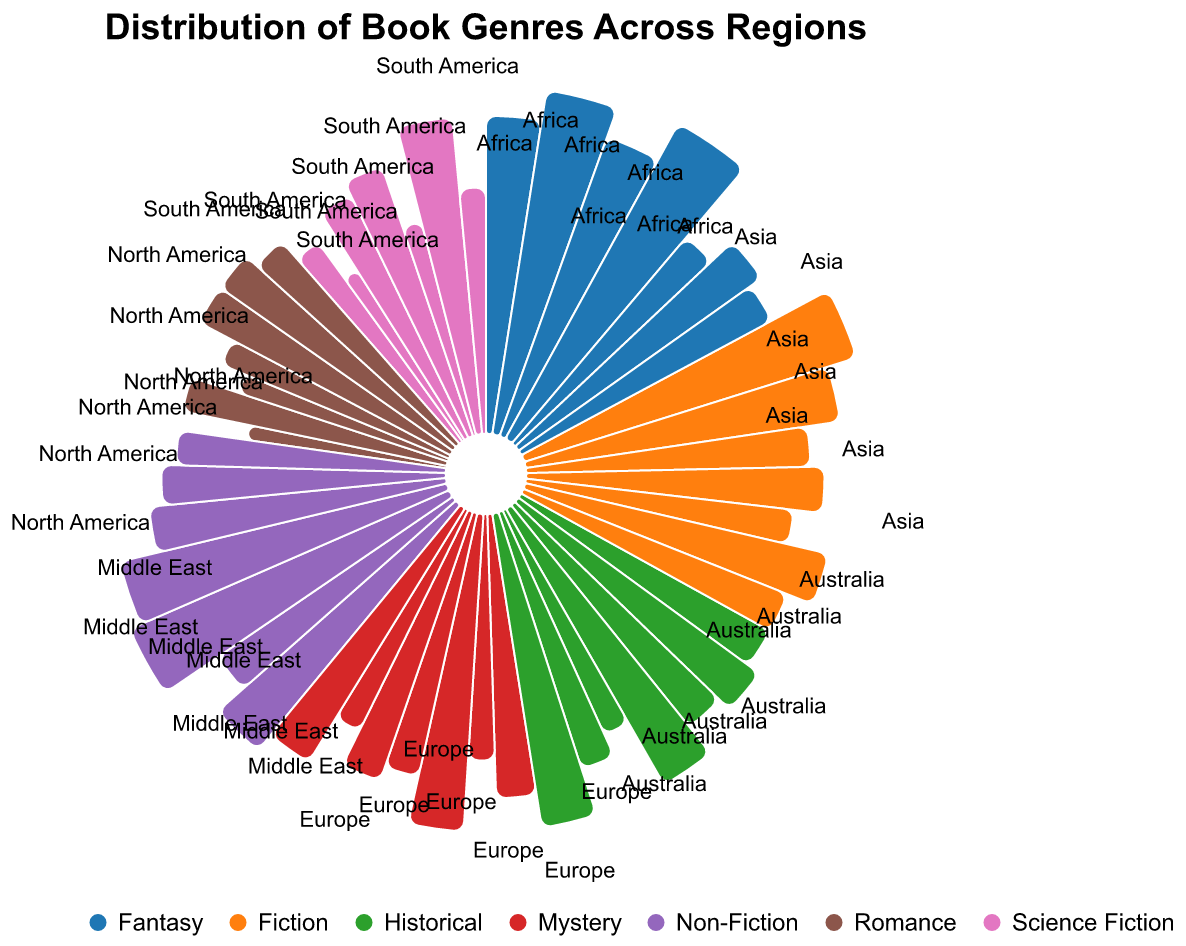Which region has the highest value for Fantasy genre? By examining the arcs of each region for the Fantasy genre, we can see that Asia has the highest value (32).
Answer: Asia In which region is Non-Fiction the most popular? By looking at the Non-Fiction arcs for all regions, Europe shows the highest value (30).
Answer: Europe How does the value of Fiction in North America compare to that in South America? The Fiction arcs for North America and South America are compared, showing 30 for North America and 25 for South America. North America's value is higher.
Answer: North America What is the combined value of Science Fiction and Fantasy genres in Australia? Adding the values of Science Fiction (25) and Fantasy (22) genres in Australia results in 25 + 22 = 47.
Answer: 47 Which genre is the least represented in Africa? Looking at the arcs for each genre in Africa, Science Fiction has the smallest value (12).
Answer: Science Fiction Which region has the most even distribution across all genres? Observing the spread of values across genres, Europe and Asia both appear relatively balanced, but Asia has slightly more variation in values compared to Europe's central value around 20-30. Therefore, Europe has the most even distribution.
Answer: Europe What is the difference in value between Historical and Romance genres in Asia? The value for Historical in Asia is 25, and for Romance, it is 15. The difference is 25 - 15 = 10.
Answer: 10 Which genre has the highest cumulative value across all regions? Adding the values for each genre across all regions, Fantasy has the highest cumulative value (172).
Answer: Fantasy What is the rank of Fantasy genre in terms of value in North America? In North America, the Fantasy genre value (25) is compared to other genres. It ranks 2nd after Fiction (30).
Answer: 2nd How many regions have a higher value for Mystery than for Science Fiction? By comparing the values of Mystery and Science Fiction for each region, North America (20 vs 15), Europe (25 vs 18), Africa (20 vs 12), and Middle East (22 vs 15) have higher values for Mystery, totaling 4 regions.
Answer: 4 regions 